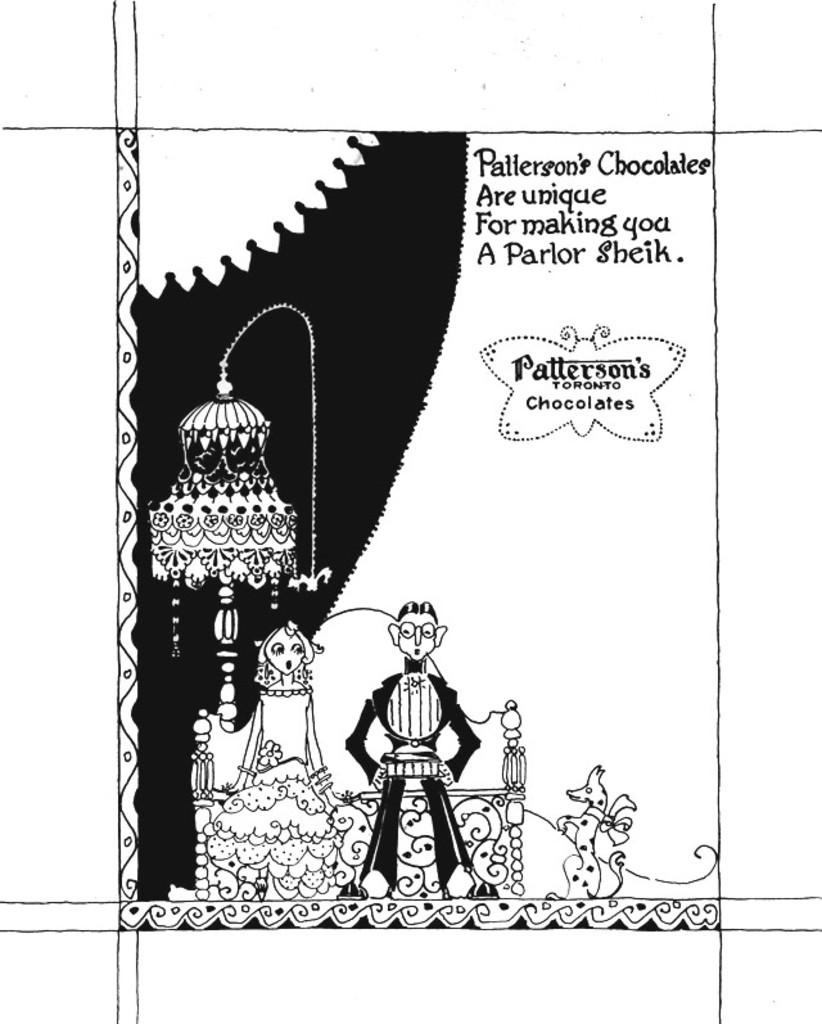What type of characters are present in the image? There are cartoon characters in the image. Is there any text included in the image? Yes, there is text written at the top of the image. What color scheme is used in the image? The image is in black and white. What type of vegetable is being used as a prop by one of the cartoon characters in the image? There is no vegetable present in the image; it features cartoon characters and text in black and white. 